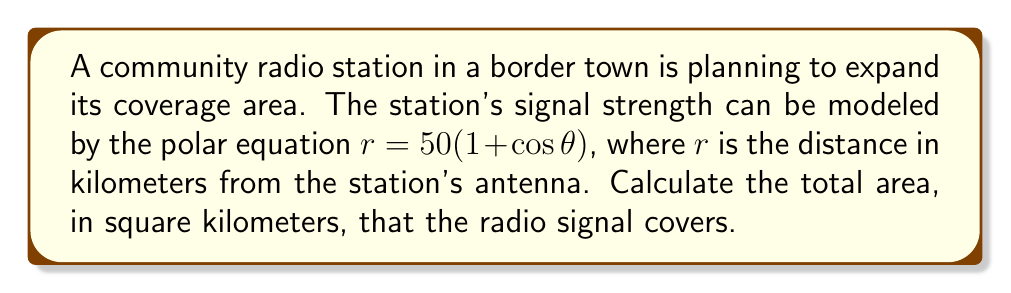Can you answer this question? To solve this problem, we need to follow these steps:

1) The area of a region in polar coordinates is given by the formula:

   $$ A = \frac{1}{2} \int_{\theta_1}^{\theta_2} r^2 d\theta $$

2) In this case, the equation $r = 50(1 + \cos\theta)$ represents a cardioid. The cardioid makes a complete loop from $\theta = 0$ to $\theta = 2\pi$.

3) Substituting our equation into the area formula:

   $$ A = \frac{1}{2} \int_{0}^{2\pi} [50(1 + \cos\theta)]^2 d\theta $$

4) Expand the squared term:

   $$ A = \frac{1}{2} \int_{0}^{2\pi} 2500(1 + 2\cos\theta + \cos^2\theta) d\theta $$

5) Distribute the 2500:

   $$ A = 1250 \int_{0}^{2\pi} (1 + 2\cos\theta + \cos^2\theta) d\theta $$

6) Integrate each term:

   $$ A = 1250 [\theta + 2\sin\theta + \frac{1}{2}\theta + \frac{1}{4}\sin(2\theta)]_{0}^{2\pi} $$

7) Evaluate the integral:

   $$ A = 1250 [(2\pi + 0 + \pi + 0) - (0 + 0 + 0 + 0)] $$

8) Simplify:

   $$ A = 1250 (3\pi) = 3750\pi $$

Therefore, the area covered by the radio signal is $3750\pi$ square kilometers.
Answer: $3750\pi$ square kilometers 